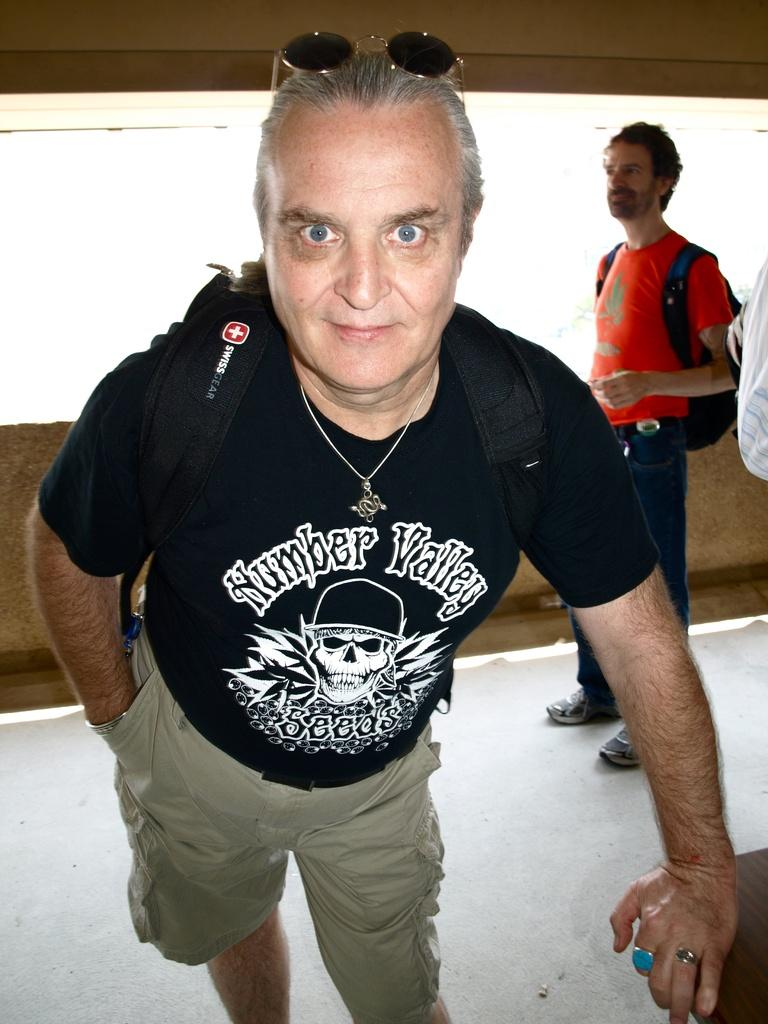<image>
Describe the image concisely. A man with wild eyes wears a Swiss gear backpack and a black shirt that says Number Valley 